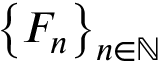<formula> <loc_0><loc_0><loc_500><loc_500>\left \{ F _ { n } \right \} _ { n \in \mathbb { N } }</formula> 